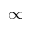Convert formula to latex. <formula><loc_0><loc_0><loc_500><loc_500>\infty</formula> 